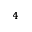<formula> <loc_0><loc_0><loc_500><loc_500>_ { 4 }</formula> 